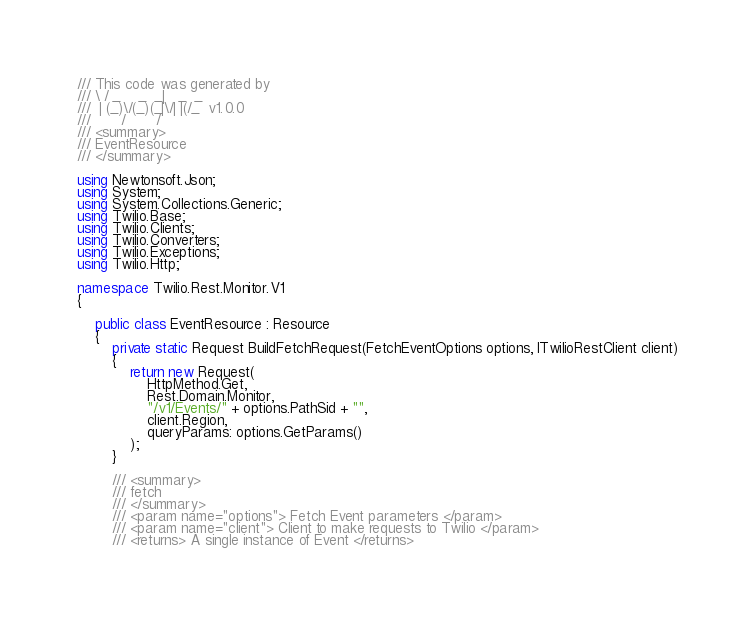Convert code to text. <code><loc_0><loc_0><loc_500><loc_500><_C#_>/// This code was generated by
/// \ / _    _  _|   _  _
///  | (_)\/(_)(_|\/| |(/_  v1.0.0
///       /       /
/// <summary>
/// EventResource
/// </summary>

using Newtonsoft.Json;
using System;
using System.Collections.Generic;
using Twilio.Base;
using Twilio.Clients;
using Twilio.Converters;
using Twilio.Exceptions;
using Twilio.Http;

namespace Twilio.Rest.Monitor.V1
{

    public class EventResource : Resource
    {
        private static Request BuildFetchRequest(FetchEventOptions options, ITwilioRestClient client)
        {
            return new Request(
                HttpMethod.Get,
                Rest.Domain.Monitor,
                "/v1/Events/" + options.PathSid + "",
                client.Region,
                queryParams: options.GetParams()
            );
        }

        /// <summary>
        /// fetch
        /// </summary>
        /// <param name="options"> Fetch Event parameters </param>
        /// <param name="client"> Client to make requests to Twilio </param>
        /// <returns> A single instance of Event </returns></code> 